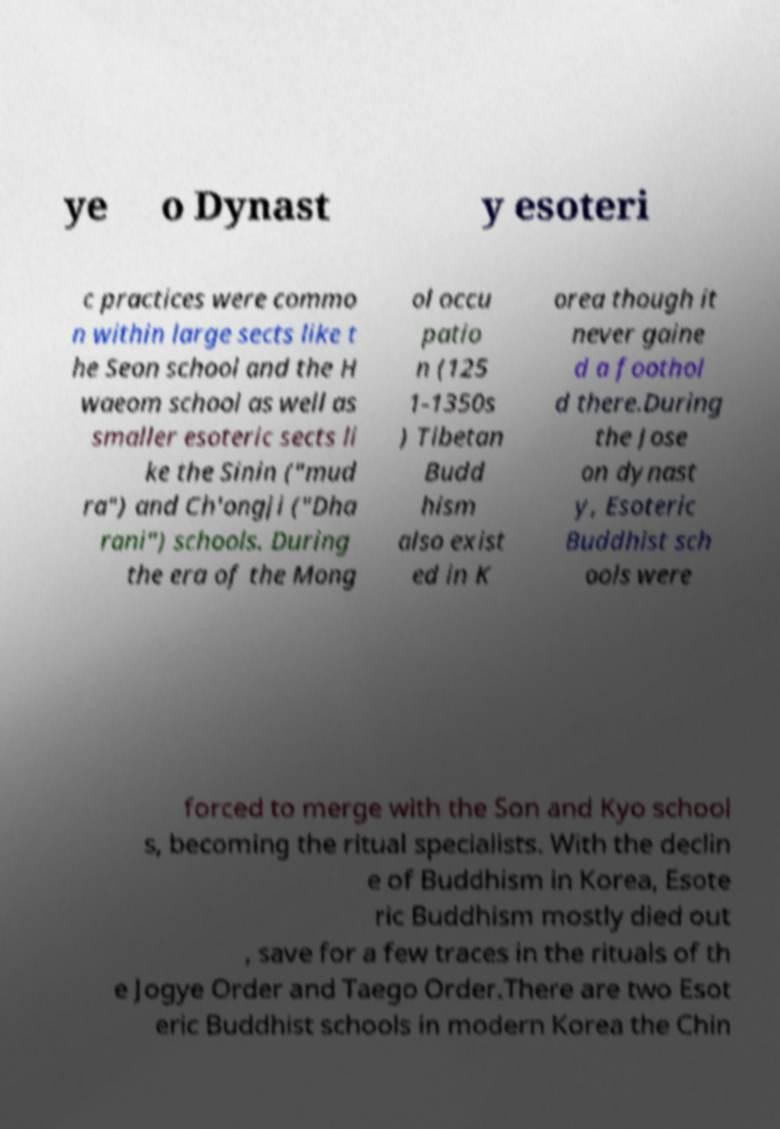There's text embedded in this image that I need extracted. Can you transcribe it verbatim? ye o Dynast y esoteri c practices were commo n within large sects like t he Seon school and the H waeom school as well as smaller esoteric sects li ke the Sinin ("mud ra") and Ch'ongji ("Dha rani") schools. During the era of the Mong ol occu patio n (125 1-1350s ) Tibetan Budd hism also exist ed in K orea though it never gaine d a foothol d there.During the Jose on dynast y, Esoteric Buddhist sch ools were forced to merge with the Son and Kyo school s, becoming the ritual specialists. With the declin e of Buddhism in Korea, Esote ric Buddhism mostly died out , save for a few traces in the rituals of th e Jogye Order and Taego Order.There are two Esot eric Buddhist schools in modern Korea the Chin 